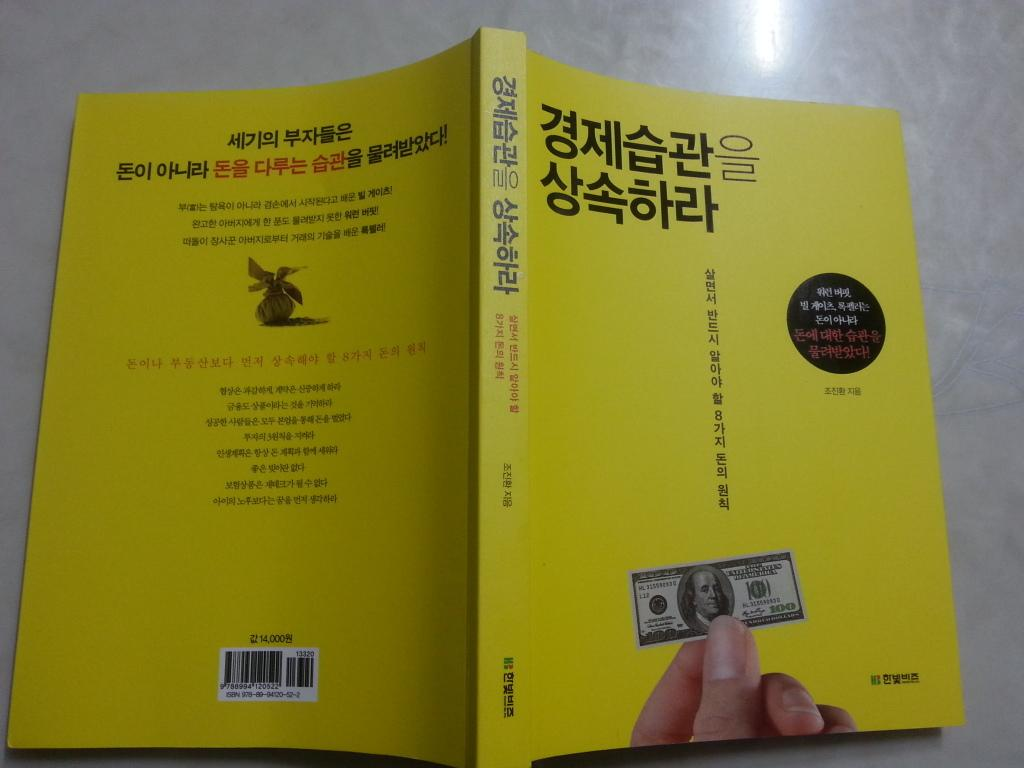<image>
Give a short and clear explanation of the subsequent image. A yellow book has the number 14,000 above the bar code on the back cover. 